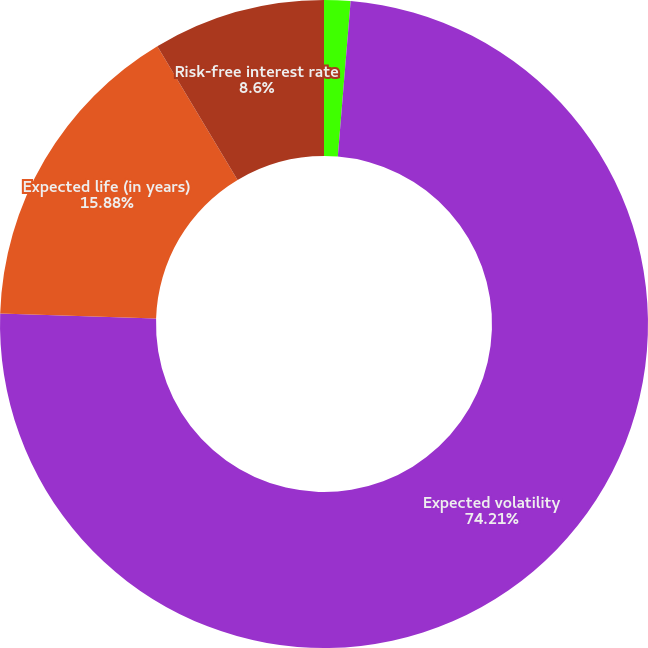Convert chart to OTSL. <chart><loc_0><loc_0><loc_500><loc_500><pie_chart><fcel>Expected dividend yield<fcel>Expected volatility<fcel>Expected life (in years)<fcel>Risk-free interest rate<nl><fcel>1.31%<fcel>74.21%<fcel>15.88%<fcel>8.6%<nl></chart> 